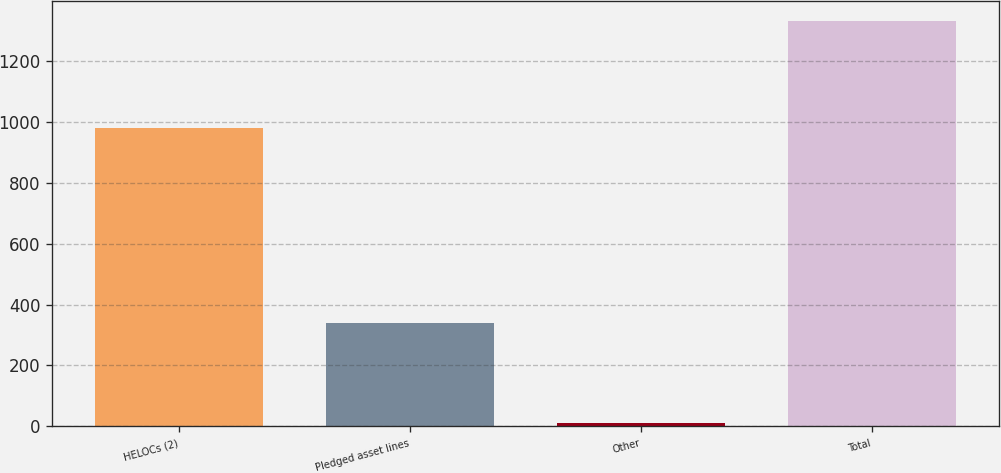Convert chart. <chart><loc_0><loc_0><loc_500><loc_500><bar_chart><fcel>HELOCs (2)<fcel>Pledged asset lines<fcel>Other<fcel>Total<nl><fcel>980<fcel>341<fcel>10<fcel>1331<nl></chart> 